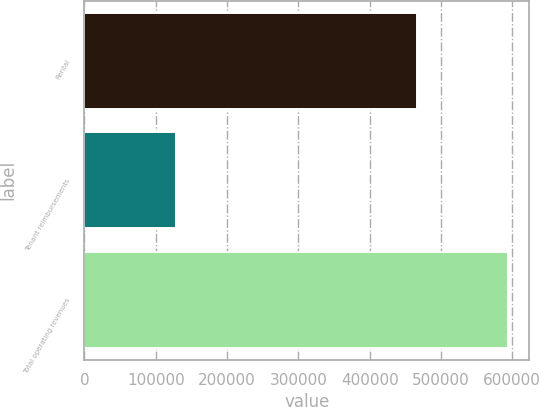Convert chart to OTSL. <chart><loc_0><loc_0><loc_500><loc_500><bar_chart><fcel>Rental<fcel>Tenant reimbursements<fcel>Total operating revenues<nl><fcel>465841<fcel>128429<fcel>594270<nl></chart> 